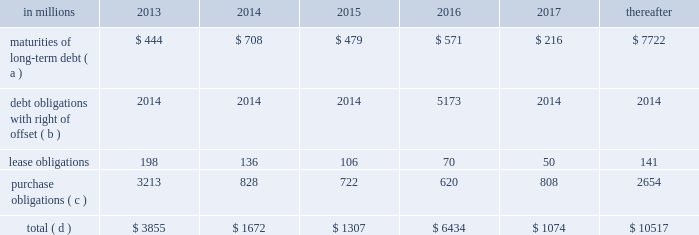Through current cash balances and cash from oper- ations .
Additionally , the company has existing credit facilities totaling $ 2.5 billion .
The company was in compliance with all its debt covenants at december 31 , 2012 .
The company 2019s financial covenants require the maintenance of a minimum net worth of $ 9 billion and a total debt-to- capital ratio of less than 60% ( 60 % ) .
Net worth is defined as the sum of common stock , paid-in capital and retained earnings , less treasury stock plus any cumulative goodwill impairment charges .
The calcu- lation also excludes accumulated other compre- hensive income/loss and nonrecourse financial liabilities of special purpose entities .
The total debt- to-capital ratio is defined as total debt divided by the sum of total debt plus net worth .
At december 31 , 2012 , international paper 2019s net worth was $ 13.9 bil- lion , and the total-debt-to-capital ratio was 42% ( 42 % ) .
The company will continue to rely upon debt and capital markets for the majority of any necessary long-term funding not provided by operating cash flows .
Funding decisions will be guided by our capi- tal structure planning objectives .
The primary goals of the company 2019s capital structure planning are to maximize financial flexibility and preserve liquidity while reducing interest expense .
The majority of international paper 2019s debt is accessed through global public capital markets where we have a wide base of investors .
Maintaining an investment grade credit rating is an important element of international paper 2019s financing strategy .
At december 31 , 2012 , the company held long-term credit ratings of bbb ( stable outlook ) and baa3 ( stable outlook ) by s&p and moody 2019s , respectively .
Contractual obligations for future payments under existing debt and lease commitments and purchase obligations at december 31 , 2012 , were as follows: .
( a ) total debt includes scheduled principal payments only .
( b ) represents debt obligations borrowed from non-consolidated variable interest entities for which international paper has , and intends to effect , a legal right to offset these obligations with investments held in the entities .
Accordingly , in its con- solidated balance sheet at december 31 , 2012 , international paper has offset approximately $ 5.2 billion of interests in the entities against this $ 5.2 billion of debt obligations held by the entities ( see note 11 variable interest entities and preferred securities of subsidiaries on pages 69 through 72 in item 8 .
Financial statements and supplementary data ) .
( c ) includes $ 3.6 billion relating to fiber supply agreements entered into at the time of the 2006 transformation plan forest- land sales and in conjunction with the 2008 acquisition of weyerhaeuser company 2019s containerboard , packaging and recycling business .
( d ) not included in the above table due to the uncertainty as to the amount and timing of the payment are unrecognized tax bene- fits of approximately $ 620 million .
We consider the undistributed earnings of our for- eign subsidiaries as of december 31 , 2012 , to be indefinitely reinvested and , accordingly , no u.s .
Income taxes have been provided thereon .
As of december 31 , 2012 , the amount of cash associated with indefinitely reinvested foreign earnings was approximately $ 840 million .
We do not anticipate the need to repatriate funds to the united states to sat- isfy domestic liquidity needs arising in the ordinary course of business , including liquidity needs asso- ciated with our domestic debt service requirements .
Pension obligations and funding at december 31 , 2012 , the projected benefit obliga- tion for the company 2019s u.s .
Defined benefit plans determined under u.s .
Gaap was approximately $ 4.1 billion higher than the fair value of plan assets .
Approximately $ 3.7 billion of this amount relates to plans that are subject to minimum funding require- ments .
Under current irs funding rules , the calcu- lation of minimum funding requirements differs from the calculation of the present value of plan benefits ( the projected benefit obligation ) for accounting purposes .
In december 2008 , the worker , retiree and employer recovery act of 2008 ( wera ) was passed by the u.s .
Congress which provided for pension funding relief and technical corrections .
Funding contributions depend on the funding method selected by the company , and the timing of its implementation , as well as on actual demo- graphic data and the targeted funding level .
The company continually reassesses the amount and timing of any discretionary contributions and elected to make voluntary contributions totaling $ 44 million and $ 300 million for the years ended december 31 , 2012 and 2011 , respectively .
At this time , we expect that required contributions to its plans in 2013 will be approximately $ 31 million , although the company may elect to make future voluntary contributions .
The timing and amount of future contributions , which could be material , will depend on a number of factors , including the actual earnings and changes in values of plan assets and changes in interest rates .
Ilim holding s.a .
Shareholder 2019s agreement in october 2007 , in connection with the for- mation of the ilim holding s.a .
Joint venture , international paper entered into a share- holder 2019s agreement that includes provisions relating to the reconciliation of disputes among the partners .
This agreement provides that at .
What percentage of contractual obligations for future payments under existing debt and lease commitments and purchase obligations at december 31 , 2012 is short term for the year 2013? 
Computations: ((198 + 3213) / 3855)
Answer: 0.88482. 